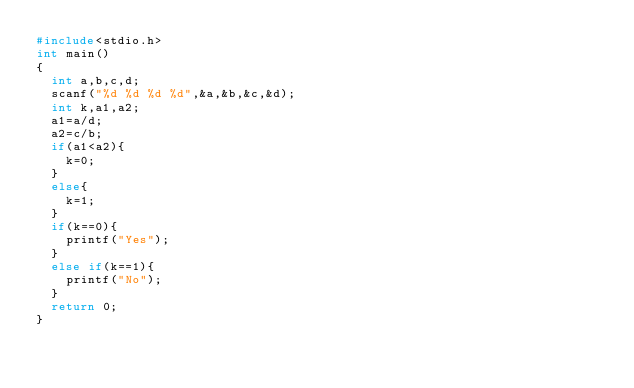Convert code to text. <code><loc_0><loc_0><loc_500><loc_500><_C_>#include<stdio.h>
int main()
{
  int a,b,c,d;
  scanf("%d %d %d %d",&a,&b,&c,&d);
  int k,a1,a2;
  a1=a/d;
  a2=c/b;
  if(a1<a2){
    k=0;
  }
  else{
    k=1;
  }
  if(k==0){
    printf("Yes");
  }
  else if(k==1){
    printf("No");
  }
  return 0;
}</code> 